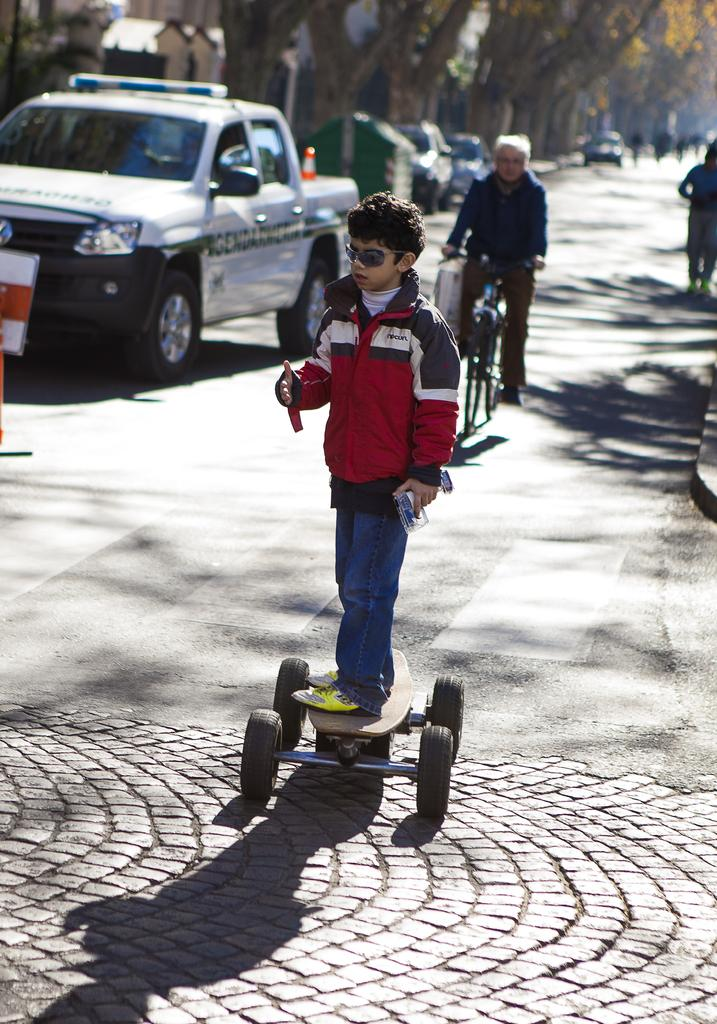Who is the main subject in the picture? The main subject in the picture is a boy. What is the boy doing in the picture? The boy is riding a skateboard in the picture. Where is the boy located in the picture? The boy is on the road in the picture. Who else is present in the picture? There is a man in the picture. What is the man doing in the picture? The man is riding a bicycle in the picture. What else can be seen on the road in the picture? Vehicles are present on the road in the picture. What can be seen in the distance in the picture? There are trees and buildings in the distance in the picture. What type of ink is the boy using to write on the road? There is no ink or writing present in the image; the boy is riding a skateboard. 